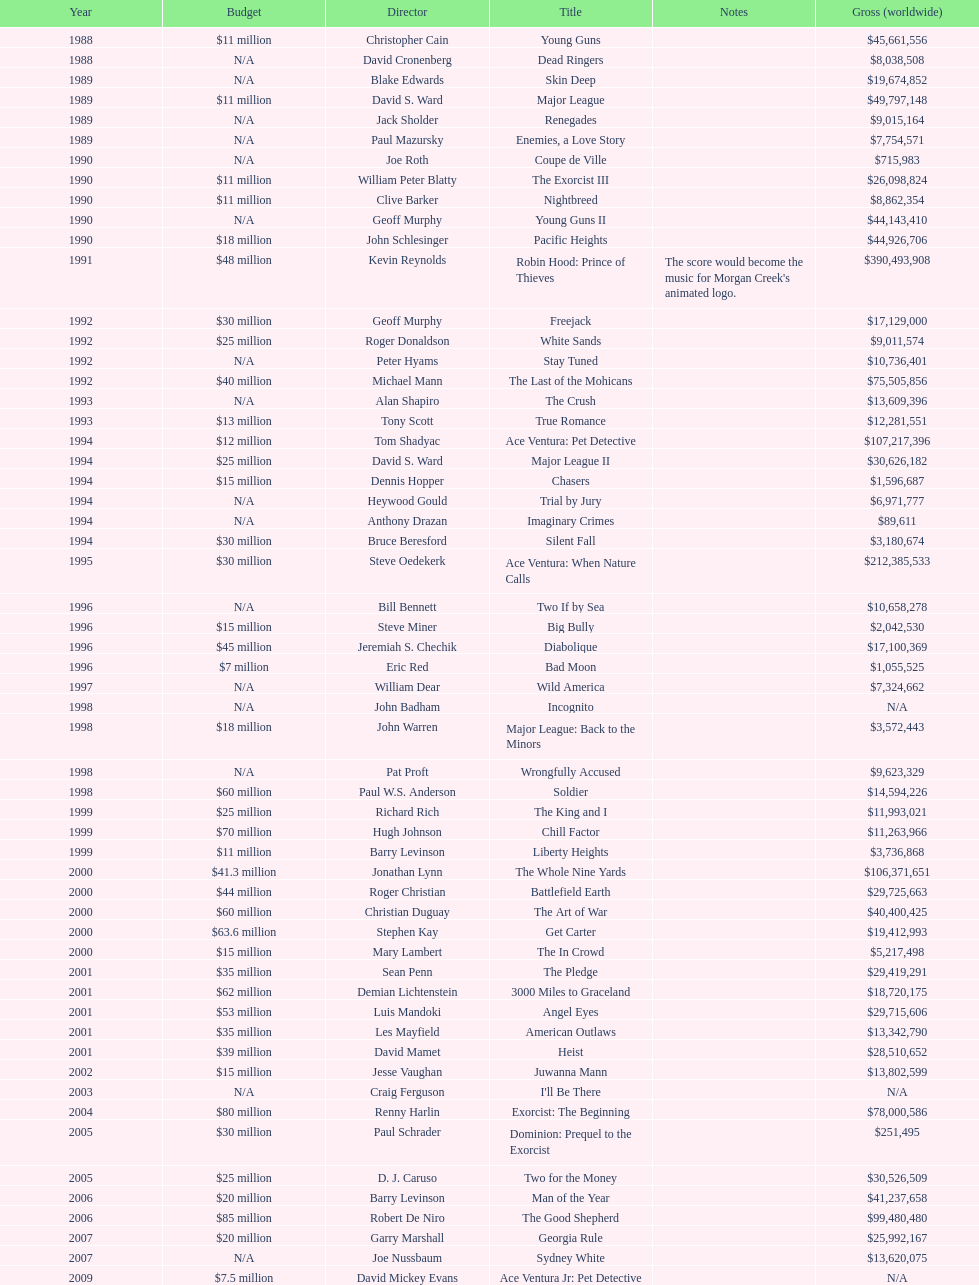What was the last movie morgan creek made for a budget under thirty million? Ace Ventura Jr: Pet Detective. 